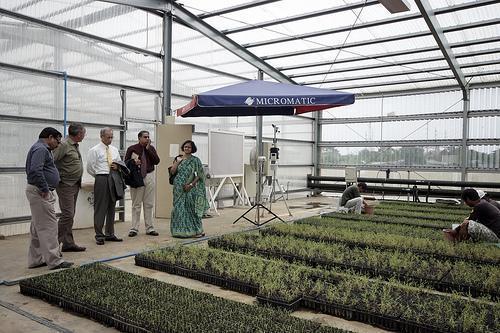How many people in the room?
Give a very brief answer. 8. 